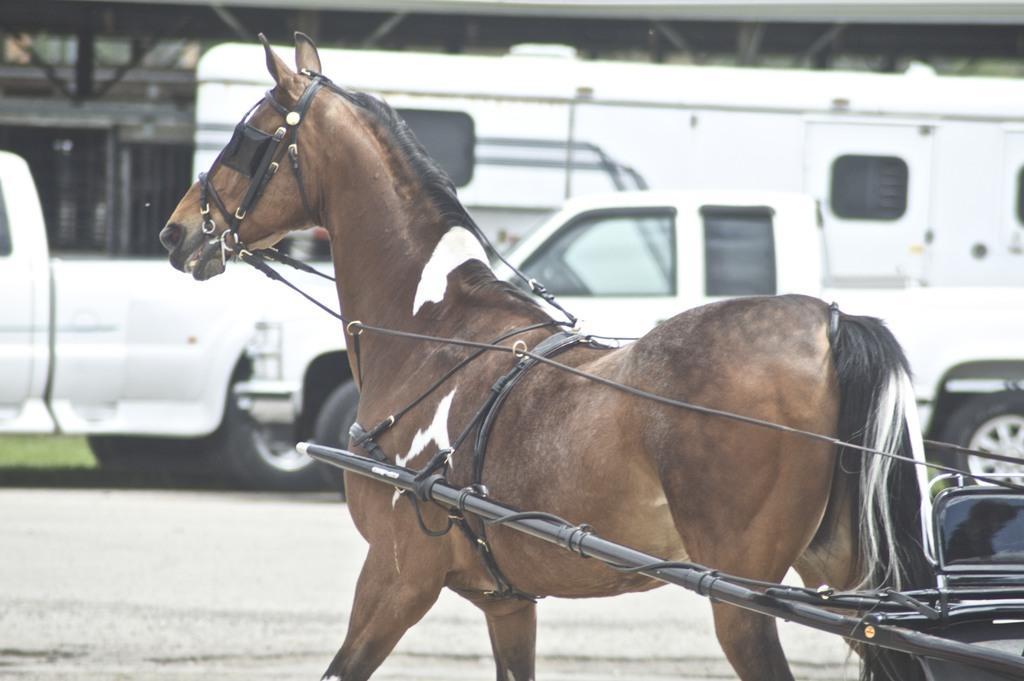Could you give a brief overview of what you see in this image? In this image there is a horse with a leash which is attached to the cart. And there are cars, bus on the road. And at the background there is a brick and grass. 